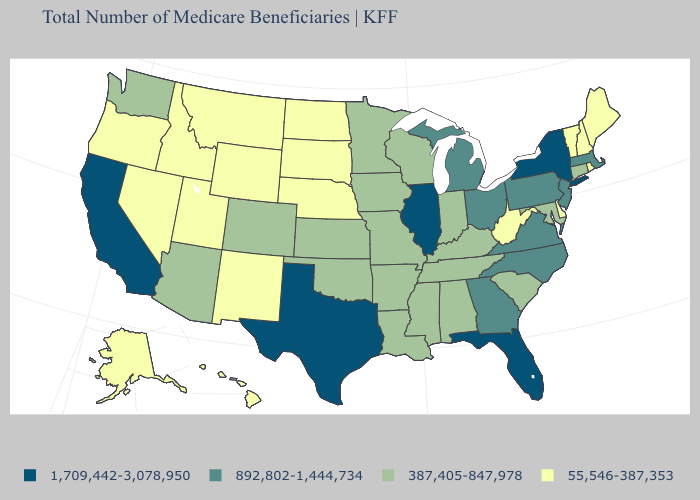Name the states that have a value in the range 387,405-847,978?
Answer briefly. Alabama, Arizona, Arkansas, Colorado, Connecticut, Indiana, Iowa, Kansas, Kentucky, Louisiana, Maryland, Minnesota, Mississippi, Missouri, Oklahoma, South Carolina, Tennessee, Washington, Wisconsin. What is the lowest value in the USA?
Write a very short answer. 55,546-387,353. Does Texas have the highest value in the USA?
Give a very brief answer. Yes. What is the value of Utah?
Give a very brief answer. 55,546-387,353. What is the value of Vermont?
Be succinct. 55,546-387,353. Does North Dakota have the lowest value in the USA?
Concise answer only. Yes. Name the states that have a value in the range 892,802-1,444,734?
Give a very brief answer. Georgia, Massachusetts, Michigan, New Jersey, North Carolina, Ohio, Pennsylvania, Virginia. Name the states that have a value in the range 55,546-387,353?
Answer briefly. Alaska, Delaware, Hawaii, Idaho, Maine, Montana, Nebraska, Nevada, New Hampshire, New Mexico, North Dakota, Oregon, Rhode Island, South Dakota, Utah, Vermont, West Virginia, Wyoming. What is the lowest value in the Northeast?
Give a very brief answer. 55,546-387,353. What is the value of Maine?
Give a very brief answer. 55,546-387,353. Name the states that have a value in the range 892,802-1,444,734?
Be succinct. Georgia, Massachusetts, Michigan, New Jersey, North Carolina, Ohio, Pennsylvania, Virginia. What is the value of South Dakota?
Quick response, please. 55,546-387,353. Does Illinois have the same value as California?
Keep it brief. Yes. 